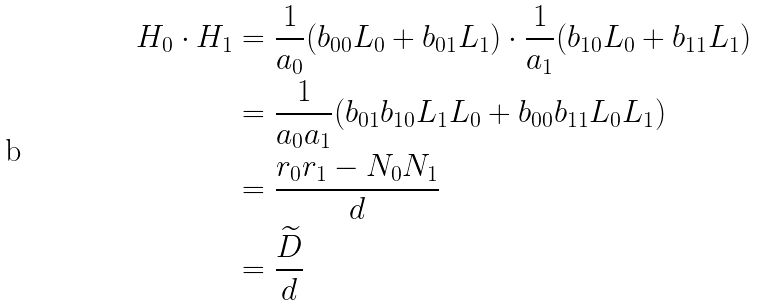Convert formula to latex. <formula><loc_0><loc_0><loc_500><loc_500>H _ { 0 } \cdot H _ { 1 } & = \frac { 1 } { a _ { 0 } } ( b _ { 0 0 } L _ { 0 } + b _ { 0 1 } L _ { 1 } ) \cdot \frac { 1 } { a _ { 1 } } ( b _ { 1 0 } L _ { 0 } + b _ { 1 1 } L _ { 1 } ) \\ & = \frac { 1 } { a _ { 0 } a _ { 1 } } ( b _ { 0 1 } b _ { 1 0 } L _ { 1 } L _ { 0 } + b _ { 0 0 } b _ { 1 1 } L _ { 0 } L _ { 1 } ) \\ & = \frac { r _ { 0 } r _ { 1 } - N _ { 0 } N _ { 1 } } { d } \\ & = \frac { \widetilde { D } } { d }</formula> 